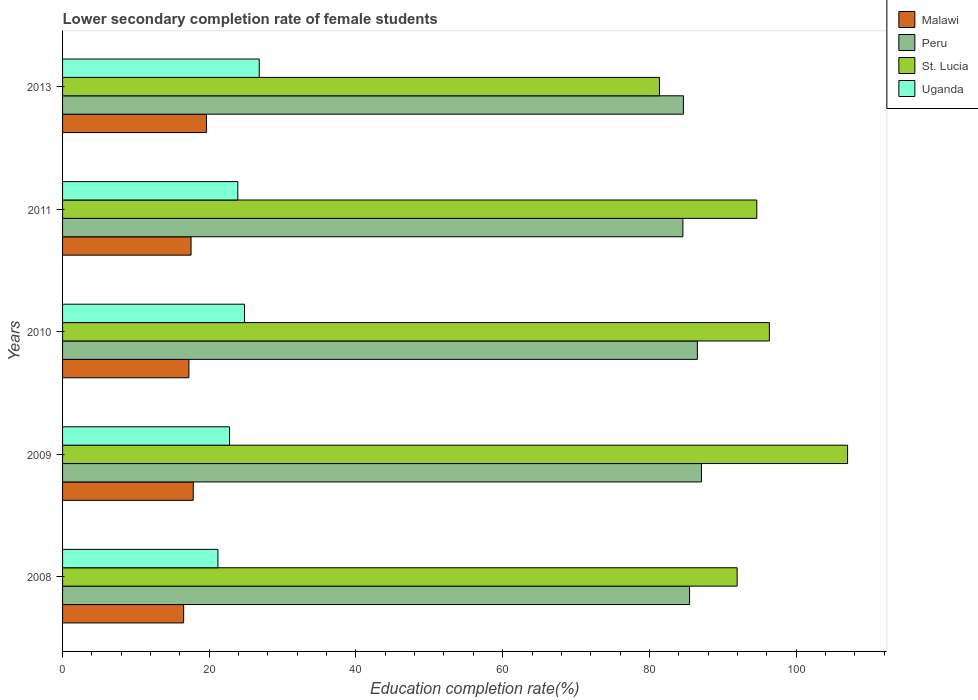How many different coloured bars are there?
Give a very brief answer. 4. How many groups of bars are there?
Your response must be concise. 5. Are the number of bars on each tick of the Y-axis equal?
Ensure brevity in your answer.  Yes. How many bars are there on the 3rd tick from the top?
Your answer should be compact. 4. What is the lower secondary completion rate of female students in Malawi in 2009?
Offer a very short reply. 17.82. Across all years, what is the maximum lower secondary completion rate of female students in St. Lucia?
Your answer should be compact. 107.03. Across all years, what is the minimum lower secondary completion rate of female students in Peru?
Make the answer very short. 84.57. In which year was the lower secondary completion rate of female students in St. Lucia maximum?
Offer a terse response. 2009. In which year was the lower secondary completion rate of female students in St. Lucia minimum?
Your response must be concise. 2013. What is the total lower secondary completion rate of female students in Uganda in the graph?
Ensure brevity in your answer.  119.46. What is the difference between the lower secondary completion rate of female students in St. Lucia in 2010 and that in 2011?
Offer a very short reply. 1.72. What is the difference between the lower secondary completion rate of female students in Uganda in 2009 and the lower secondary completion rate of female students in St. Lucia in 2008?
Offer a terse response. -69.2. What is the average lower secondary completion rate of female students in St. Lucia per year?
Offer a very short reply. 94.28. In the year 2013, what is the difference between the lower secondary completion rate of female students in Uganda and lower secondary completion rate of female students in St. Lucia?
Give a very brief answer. -54.56. What is the ratio of the lower secondary completion rate of female students in St. Lucia in 2008 to that in 2011?
Offer a terse response. 0.97. Is the difference between the lower secondary completion rate of female students in Uganda in 2009 and 2011 greater than the difference between the lower secondary completion rate of female students in St. Lucia in 2009 and 2011?
Ensure brevity in your answer.  No. What is the difference between the highest and the second highest lower secondary completion rate of female students in Peru?
Provide a short and direct response. 0.56. What is the difference between the highest and the lowest lower secondary completion rate of female students in Malawi?
Keep it short and to the point. 3.11. In how many years, is the lower secondary completion rate of female students in Peru greater than the average lower secondary completion rate of female students in Peru taken over all years?
Ensure brevity in your answer.  2. What does the 1st bar from the top in 2010 represents?
Provide a succinct answer. Uganda. What does the 1st bar from the bottom in 2008 represents?
Ensure brevity in your answer.  Malawi. Is it the case that in every year, the sum of the lower secondary completion rate of female students in Uganda and lower secondary completion rate of female students in St. Lucia is greater than the lower secondary completion rate of female students in Peru?
Give a very brief answer. Yes. How many bars are there?
Your answer should be compact. 20. Are all the bars in the graph horizontal?
Make the answer very short. Yes. What is the difference between two consecutive major ticks on the X-axis?
Give a very brief answer. 20. Where does the legend appear in the graph?
Give a very brief answer. Top right. How many legend labels are there?
Ensure brevity in your answer.  4. What is the title of the graph?
Ensure brevity in your answer.  Lower secondary completion rate of female students. Does "Aruba" appear as one of the legend labels in the graph?
Your answer should be very brief. No. What is the label or title of the X-axis?
Provide a short and direct response. Education completion rate(%). What is the Education completion rate(%) in Malawi in 2008?
Make the answer very short. 16.51. What is the Education completion rate(%) in Peru in 2008?
Offer a very short reply. 85.48. What is the Education completion rate(%) in St. Lucia in 2008?
Give a very brief answer. 91.97. What is the Education completion rate(%) in Uganda in 2008?
Your answer should be very brief. 21.18. What is the Education completion rate(%) in Malawi in 2009?
Give a very brief answer. 17.82. What is the Education completion rate(%) in Peru in 2009?
Ensure brevity in your answer.  87.1. What is the Education completion rate(%) in St. Lucia in 2009?
Keep it short and to the point. 107.03. What is the Education completion rate(%) in Uganda in 2009?
Give a very brief answer. 22.77. What is the Education completion rate(%) of Malawi in 2010?
Offer a very short reply. 17.22. What is the Education completion rate(%) in Peru in 2010?
Offer a very short reply. 86.54. What is the Education completion rate(%) in St. Lucia in 2010?
Your response must be concise. 96.36. What is the Education completion rate(%) in Uganda in 2010?
Offer a terse response. 24.8. What is the Education completion rate(%) in Malawi in 2011?
Offer a very short reply. 17.52. What is the Education completion rate(%) in Peru in 2011?
Keep it short and to the point. 84.57. What is the Education completion rate(%) of St. Lucia in 2011?
Ensure brevity in your answer.  94.65. What is the Education completion rate(%) of Uganda in 2011?
Your answer should be compact. 23.89. What is the Education completion rate(%) of Malawi in 2013?
Your answer should be compact. 19.62. What is the Education completion rate(%) in Peru in 2013?
Keep it short and to the point. 84.65. What is the Education completion rate(%) of St. Lucia in 2013?
Make the answer very short. 81.38. What is the Education completion rate(%) of Uganda in 2013?
Give a very brief answer. 26.81. Across all years, what is the maximum Education completion rate(%) in Malawi?
Make the answer very short. 19.62. Across all years, what is the maximum Education completion rate(%) of Peru?
Provide a short and direct response. 87.1. Across all years, what is the maximum Education completion rate(%) in St. Lucia?
Make the answer very short. 107.03. Across all years, what is the maximum Education completion rate(%) in Uganda?
Provide a short and direct response. 26.81. Across all years, what is the minimum Education completion rate(%) in Malawi?
Your response must be concise. 16.51. Across all years, what is the minimum Education completion rate(%) in Peru?
Give a very brief answer. 84.57. Across all years, what is the minimum Education completion rate(%) in St. Lucia?
Give a very brief answer. 81.38. Across all years, what is the minimum Education completion rate(%) in Uganda?
Provide a short and direct response. 21.18. What is the total Education completion rate(%) in Malawi in the graph?
Your response must be concise. 88.69. What is the total Education completion rate(%) of Peru in the graph?
Give a very brief answer. 428.35. What is the total Education completion rate(%) in St. Lucia in the graph?
Keep it short and to the point. 471.38. What is the total Education completion rate(%) in Uganda in the graph?
Offer a very short reply. 119.46. What is the difference between the Education completion rate(%) in Malawi in 2008 and that in 2009?
Give a very brief answer. -1.31. What is the difference between the Education completion rate(%) in Peru in 2008 and that in 2009?
Your response must be concise. -1.62. What is the difference between the Education completion rate(%) in St. Lucia in 2008 and that in 2009?
Your answer should be very brief. -15.06. What is the difference between the Education completion rate(%) of Uganda in 2008 and that in 2009?
Your answer should be compact. -1.58. What is the difference between the Education completion rate(%) of Malawi in 2008 and that in 2010?
Make the answer very short. -0.72. What is the difference between the Education completion rate(%) in Peru in 2008 and that in 2010?
Offer a terse response. -1.06. What is the difference between the Education completion rate(%) in St. Lucia in 2008 and that in 2010?
Your answer should be compact. -4.4. What is the difference between the Education completion rate(%) of Uganda in 2008 and that in 2010?
Keep it short and to the point. -3.62. What is the difference between the Education completion rate(%) in Malawi in 2008 and that in 2011?
Give a very brief answer. -1.01. What is the difference between the Education completion rate(%) of Peru in 2008 and that in 2011?
Give a very brief answer. 0.91. What is the difference between the Education completion rate(%) in St. Lucia in 2008 and that in 2011?
Your answer should be compact. -2.68. What is the difference between the Education completion rate(%) in Uganda in 2008 and that in 2011?
Ensure brevity in your answer.  -2.71. What is the difference between the Education completion rate(%) in Malawi in 2008 and that in 2013?
Provide a succinct answer. -3.11. What is the difference between the Education completion rate(%) in Peru in 2008 and that in 2013?
Your answer should be compact. 0.84. What is the difference between the Education completion rate(%) of St. Lucia in 2008 and that in 2013?
Provide a short and direct response. 10.59. What is the difference between the Education completion rate(%) in Uganda in 2008 and that in 2013?
Your answer should be very brief. -5.63. What is the difference between the Education completion rate(%) in Malawi in 2009 and that in 2010?
Offer a very short reply. 0.59. What is the difference between the Education completion rate(%) of Peru in 2009 and that in 2010?
Ensure brevity in your answer.  0.56. What is the difference between the Education completion rate(%) of St. Lucia in 2009 and that in 2010?
Offer a very short reply. 10.66. What is the difference between the Education completion rate(%) in Uganda in 2009 and that in 2010?
Ensure brevity in your answer.  -2.04. What is the difference between the Education completion rate(%) of Malawi in 2009 and that in 2011?
Provide a short and direct response. 0.3. What is the difference between the Education completion rate(%) of Peru in 2009 and that in 2011?
Your response must be concise. 2.53. What is the difference between the Education completion rate(%) of St. Lucia in 2009 and that in 2011?
Make the answer very short. 12.38. What is the difference between the Education completion rate(%) in Uganda in 2009 and that in 2011?
Make the answer very short. -1.13. What is the difference between the Education completion rate(%) in Malawi in 2009 and that in 2013?
Your answer should be very brief. -1.8. What is the difference between the Education completion rate(%) of Peru in 2009 and that in 2013?
Provide a short and direct response. 2.46. What is the difference between the Education completion rate(%) in St. Lucia in 2009 and that in 2013?
Ensure brevity in your answer.  25.65. What is the difference between the Education completion rate(%) in Uganda in 2009 and that in 2013?
Offer a very short reply. -4.05. What is the difference between the Education completion rate(%) of Malawi in 2010 and that in 2011?
Provide a succinct answer. -0.29. What is the difference between the Education completion rate(%) of Peru in 2010 and that in 2011?
Provide a short and direct response. 1.97. What is the difference between the Education completion rate(%) in St. Lucia in 2010 and that in 2011?
Offer a terse response. 1.72. What is the difference between the Education completion rate(%) of Uganda in 2010 and that in 2011?
Offer a very short reply. 0.91. What is the difference between the Education completion rate(%) in Malawi in 2010 and that in 2013?
Ensure brevity in your answer.  -2.39. What is the difference between the Education completion rate(%) in Peru in 2010 and that in 2013?
Give a very brief answer. 1.9. What is the difference between the Education completion rate(%) of St. Lucia in 2010 and that in 2013?
Make the answer very short. 14.99. What is the difference between the Education completion rate(%) in Uganda in 2010 and that in 2013?
Give a very brief answer. -2.01. What is the difference between the Education completion rate(%) in Malawi in 2011 and that in 2013?
Offer a terse response. -2.1. What is the difference between the Education completion rate(%) in Peru in 2011 and that in 2013?
Ensure brevity in your answer.  -0.07. What is the difference between the Education completion rate(%) in St. Lucia in 2011 and that in 2013?
Your answer should be very brief. 13.27. What is the difference between the Education completion rate(%) in Uganda in 2011 and that in 2013?
Offer a very short reply. -2.92. What is the difference between the Education completion rate(%) in Malawi in 2008 and the Education completion rate(%) in Peru in 2009?
Your response must be concise. -70.59. What is the difference between the Education completion rate(%) in Malawi in 2008 and the Education completion rate(%) in St. Lucia in 2009?
Provide a succinct answer. -90.52. What is the difference between the Education completion rate(%) of Malawi in 2008 and the Education completion rate(%) of Uganda in 2009?
Ensure brevity in your answer.  -6.26. What is the difference between the Education completion rate(%) in Peru in 2008 and the Education completion rate(%) in St. Lucia in 2009?
Keep it short and to the point. -21.54. What is the difference between the Education completion rate(%) of Peru in 2008 and the Education completion rate(%) of Uganda in 2009?
Provide a short and direct response. 62.72. What is the difference between the Education completion rate(%) of St. Lucia in 2008 and the Education completion rate(%) of Uganda in 2009?
Make the answer very short. 69.2. What is the difference between the Education completion rate(%) of Malawi in 2008 and the Education completion rate(%) of Peru in 2010?
Offer a terse response. -70.04. What is the difference between the Education completion rate(%) of Malawi in 2008 and the Education completion rate(%) of St. Lucia in 2010?
Your answer should be very brief. -79.85. What is the difference between the Education completion rate(%) in Malawi in 2008 and the Education completion rate(%) in Uganda in 2010?
Offer a very short reply. -8.29. What is the difference between the Education completion rate(%) in Peru in 2008 and the Education completion rate(%) in St. Lucia in 2010?
Offer a very short reply. -10.88. What is the difference between the Education completion rate(%) in Peru in 2008 and the Education completion rate(%) in Uganda in 2010?
Your answer should be very brief. 60.68. What is the difference between the Education completion rate(%) in St. Lucia in 2008 and the Education completion rate(%) in Uganda in 2010?
Provide a short and direct response. 67.17. What is the difference between the Education completion rate(%) of Malawi in 2008 and the Education completion rate(%) of Peru in 2011?
Provide a succinct answer. -68.06. What is the difference between the Education completion rate(%) in Malawi in 2008 and the Education completion rate(%) in St. Lucia in 2011?
Your answer should be very brief. -78.14. What is the difference between the Education completion rate(%) in Malawi in 2008 and the Education completion rate(%) in Uganda in 2011?
Your answer should be compact. -7.38. What is the difference between the Education completion rate(%) of Peru in 2008 and the Education completion rate(%) of St. Lucia in 2011?
Make the answer very short. -9.16. What is the difference between the Education completion rate(%) in Peru in 2008 and the Education completion rate(%) in Uganda in 2011?
Your response must be concise. 61.59. What is the difference between the Education completion rate(%) in St. Lucia in 2008 and the Education completion rate(%) in Uganda in 2011?
Ensure brevity in your answer.  68.08. What is the difference between the Education completion rate(%) in Malawi in 2008 and the Education completion rate(%) in Peru in 2013?
Ensure brevity in your answer.  -68.14. What is the difference between the Education completion rate(%) of Malawi in 2008 and the Education completion rate(%) of St. Lucia in 2013?
Make the answer very short. -64.87. What is the difference between the Education completion rate(%) of Malawi in 2008 and the Education completion rate(%) of Uganda in 2013?
Make the answer very short. -10.31. What is the difference between the Education completion rate(%) in Peru in 2008 and the Education completion rate(%) in St. Lucia in 2013?
Make the answer very short. 4.11. What is the difference between the Education completion rate(%) in Peru in 2008 and the Education completion rate(%) in Uganda in 2013?
Keep it short and to the point. 58.67. What is the difference between the Education completion rate(%) of St. Lucia in 2008 and the Education completion rate(%) of Uganda in 2013?
Give a very brief answer. 65.15. What is the difference between the Education completion rate(%) in Malawi in 2009 and the Education completion rate(%) in Peru in 2010?
Your answer should be compact. -68.73. What is the difference between the Education completion rate(%) in Malawi in 2009 and the Education completion rate(%) in St. Lucia in 2010?
Give a very brief answer. -78.54. What is the difference between the Education completion rate(%) of Malawi in 2009 and the Education completion rate(%) of Uganda in 2010?
Offer a very short reply. -6.98. What is the difference between the Education completion rate(%) in Peru in 2009 and the Education completion rate(%) in St. Lucia in 2010?
Provide a short and direct response. -9.26. What is the difference between the Education completion rate(%) of Peru in 2009 and the Education completion rate(%) of Uganda in 2010?
Provide a succinct answer. 62.3. What is the difference between the Education completion rate(%) in St. Lucia in 2009 and the Education completion rate(%) in Uganda in 2010?
Keep it short and to the point. 82.22. What is the difference between the Education completion rate(%) in Malawi in 2009 and the Education completion rate(%) in Peru in 2011?
Ensure brevity in your answer.  -66.75. What is the difference between the Education completion rate(%) of Malawi in 2009 and the Education completion rate(%) of St. Lucia in 2011?
Your answer should be very brief. -76.83. What is the difference between the Education completion rate(%) of Malawi in 2009 and the Education completion rate(%) of Uganda in 2011?
Your response must be concise. -6.07. What is the difference between the Education completion rate(%) in Peru in 2009 and the Education completion rate(%) in St. Lucia in 2011?
Keep it short and to the point. -7.55. What is the difference between the Education completion rate(%) in Peru in 2009 and the Education completion rate(%) in Uganda in 2011?
Offer a very short reply. 63.21. What is the difference between the Education completion rate(%) of St. Lucia in 2009 and the Education completion rate(%) of Uganda in 2011?
Keep it short and to the point. 83.13. What is the difference between the Education completion rate(%) in Malawi in 2009 and the Education completion rate(%) in Peru in 2013?
Your response must be concise. -66.83. What is the difference between the Education completion rate(%) of Malawi in 2009 and the Education completion rate(%) of St. Lucia in 2013?
Make the answer very short. -63.56. What is the difference between the Education completion rate(%) of Malawi in 2009 and the Education completion rate(%) of Uganda in 2013?
Provide a short and direct response. -9. What is the difference between the Education completion rate(%) of Peru in 2009 and the Education completion rate(%) of St. Lucia in 2013?
Your answer should be very brief. 5.72. What is the difference between the Education completion rate(%) of Peru in 2009 and the Education completion rate(%) of Uganda in 2013?
Offer a terse response. 60.29. What is the difference between the Education completion rate(%) of St. Lucia in 2009 and the Education completion rate(%) of Uganda in 2013?
Provide a short and direct response. 80.21. What is the difference between the Education completion rate(%) of Malawi in 2010 and the Education completion rate(%) of Peru in 2011?
Keep it short and to the point. -67.35. What is the difference between the Education completion rate(%) in Malawi in 2010 and the Education completion rate(%) in St. Lucia in 2011?
Keep it short and to the point. -77.42. What is the difference between the Education completion rate(%) in Malawi in 2010 and the Education completion rate(%) in Uganda in 2011?
Offer a very short reply. -6.67. What is the difference between the Education completion rate(%) of Peru in 2010 and the Education completion rate(%) of St. Lucia in 2011?
Provide a short and direct response. -8.1. What is the difference between the Education completion rate(%) in Peru in 2010 and the Education completion rate(%) in Uganda in 2011?
Keep it short and to the point. 62.65. What is the difference between the Education completion rate(%) in St. Lucia in 2010 and the Education completion rate(%) in Uganda in 2011?
Keep it short and to the point. 72.47. What is the difference between the Education completion rate(%) in Malawi in 2010 and the Education completion rate(%) in Peru in 2013?
Ensure brevity in your answer.  -67.42. What is the difference between the Education completion rate(%) of Malawi in 2010 and the Education completion rate(%) of St. Lucia in 2013?
Your response must be concise. -64.15. What is the difference between the Education completion rate(%) of Malawi in 2010 and the Education completion rate(%) of Uganda in 2013?
Your answer should be very brief. -9.59. What is the difference between the Education completion rate(%) in Peru in 2010 and the Education completion rate(%) in St. Lucia in 2013?
Your response must be concise. 5.17. What is the difference between the Education completion rate(%) in Peru in 2010 and the Education completion rate(%) in Uganda in 2013?
Your answer should be very brief. 59.73. What is the difference between the Education completion rate(%) in St. Lucia in 2010 and the Education completion rate(%) in Uganda in 2013?
Make the answer very short. 69.55. What is the difference between the Education completion rate(%) in Malawi in 2011 and the Education completion rate(%) in Peru in 2013?
Make the answer very short. -67.13. What is the difference between the Education completion rate(%) of Malawi in 2011 and the Education completion rate(%) of St. Lucia in 2013?
Ensure brevity in your answer.  -63.86. What is the difference between the Education completion rate(%) in Malawi in 2011 and the Education completion rate(%) in Uganda in 2013?
Offer a terse response. -9.29. What is the difference between the Education completion rate(%) in Peru in 2011 and the Education completion rate(%) in St. Lucia in 2013?
Provide a short and direct response. 3.19. What is the difference between the Education completion rate(%) in Peru in 2011 and the Education completion rate(%) in Uganda in 2013?
Your answer should be very brief. 57.76. What is the difference between the Education completion rate(%) in St. Lucia in 2011 and the Education completion rate(%) in Uganda in 2013?
Offer a very short reply. 67.83. What is the average Education completion rate(%) in Malawi per year?
Ensure brevity in your answer.  17.74. What is the average Education completion rate(%) of Peru per year?
Offer a terse response. 85.67. What is the average Education completion rate(%) of St. Lucia per year?
Give a very brief answer. 94.28. What is the average Education completion rate(%) in Uganda per year?
Keep it short and to the point. 23.89. In the year 2008, what is the difference between the Education completion rate(%) in Malawi and Education completion rate(%) in Peru?
Keep it short and to the point. -68.98. In the year 2008, what is the difference between the Education completion rate(%) of Malawi and Education completion rate(%) of St. Lucia?
Provide a succinct answer. -75.46. In the year 2008, what is the difference between the Education completion rate(%) in Malawi and Education completion rate(%) in Uganda?
Provide a succinct answer. -4.68. In the year 2008, what is the difference between the Education completion rate(%) in Peru and Education completion rate(%) in St. Lucia?
Provide a short and direct response. -6.48. In the year 2008, what is the difference between the Education completion rate(%) of Peru and Education completion rate(%) of Uganda?
Your response must be concise. 64.3. In the year 2008, what is the difference between the Education completion rate(%) in St. Lucia and Education completion rate(%) in Uganda?
Ensure brevity in your answer.  70.78. In the year 2009, what is the difference between the Education completion rate(%) of Malawi and Education completion rate(%) of Peru?
Your answer should be compact. -69.28. In the year 2009, what is the difference between the Education completion rate(%) in Malawi and Education completion rate(%) in St. Lucia?
Offer a terse response. -89.21. In the year 2009, what is the difference between the Education completion rate(%) in Malawi and Education completion rate(%) in Uganda?
Your answer should be very brief. -4.95. In the year 2009, what is the difference between the Education completion rate(%) in Peru and Education completion rate(%) in St. Lucia?
Make the answer very short. -19.93. In the year 2009, what is the difference between the Education completion rate(%) in Peru and Education completion rate(%) in Uganda?
Your answer should be very brief. 64.33. In the year 2009, what is the difference between the Education completion rate(%) of St. Lucia and Education completion rate(%) of Uganda?
Give a very brief answer. 84.26. In the year 2010, what is the difference between the Education completion rate(%) in Malawi and Education completion rate(%) in Peru?
Offer a terse response. -69.32. In the year 2010, what is the difference between the Education completion rate(%) of Malawi and Education completion rate(%) of St. Lucia?
Your answer should be compact. -79.14. In the year 2010, what is the difference between the Education completion rate(%) of Malawi and Education completion rate(%) of Uganda?
Ensure brevity in your answer.  -7.58. In the year 2010, what is the difference between the Education completion rate(%) of Peru and Education completion rate(%) of St. Lucia?
Make the answer very short. -9.82. In the year 2010, what is the difference between the Education completion rate(%) of Peru and Education completion rate(%) of Uganda?
Ensure brevity in your answer.  61.74. In the year 2010, what is the difference between the Education completion rate(%) in St. Lucia and Education completion rate(%) in Uganda?
Keep it short and to the point. 71.56. In the year 2011, what is the difference between the Education completion rate(%) in Malawi and Education completion rate(%) in Peru?
Your answer should be compact. -67.05. In the year 2011, what is the difference between the Education completion rate(%) of Malawi and Education completion rate(%) of St. Lucia?
Provide a short and direct response. -77.13. In the year 2011, what is the difference between the Education completion rate(%) of Malawi and Education completion rate(%) of Uganda?
Make the answer very short. -6.37. In the year 2011, what is the difference between the Education completion rate(%) in Peru and Education completion rate(%) in St. Lucia?
Ensure brevity in your answer.  -10.08. In the year 2011, what is the difference between the Education completion rate(%) of Peru and Education completion rate(%) of Uganda?
Your answer should be compact. 60.68. In the year 2011, what is the difference between the Education completion rate(%) of St. Lucia and Education completion rate(%) of Uganda?
Your answer should be very brief. 70.76. In the year 2013, what is the difference between the Education completion rate(%) of Malawi and Education completion rate(%) of Peru?
Keep it short and to the point. -65.03. In the year 2013, what is the difference between the Education completion rate(%) of Malawi and Education completion rate(%) of St. Lucia?
Offer a very short reply. -61.76. In the year 2013, what is the difference between the Education completion rate(%) of Malawi and Education completion rate(%) of Uganda?
Give a very brief answer. -7.19. In the year 2013, what is the difference between the Education completion rate(%) in Peru and Education completion rate(%) in St. Lucia?
Provide a succinct answer. 3.27. In the year 2013, what is the difference between the Education completion rate(%) in Peru and Education completion rate(%) in Uganda?
Make the answer very short. 57.83. In the year 2013, what is the difference between the Education completion rate(%) in St. Lucia and Education completion rate(%) in Uganda?
Keep it short and to the point. 54.56. What is the ratio of the Education completion rate(%) in Malawi in 2008 to that in 2009?
Provide a short and direct response. 0.93. What is the ratio of the Education completion rate(%) in Peru in 2008 to that in 2009?
Your answer should be compact. 0.98. What is the ratio of the Education completion rate(%) of St. Lucia in 2008 to that in 2009?
Your response must be concise. 0.86. What is the ratio of the Education completion rate(%) in Uganda in 2008 to that in 2009?
Make the answer very short. 0.93. What is the ratio of the Education completion rate(%) in Malawi in 2008 to that in 2010?
Your response must be concise. 0.96. What is the ratio of the Education completion rate(%) in Peru in 2008 to that in 2010?
Offer a terse response. 0.99. What is the ratio of the Education completion rate(%) in St. Lucia in 2008 to that in 2010?
Provide a succinct answer. 0.95. What is the ratio of the Education completion rate(%) in Uganda in 2008 to that in 2010?
Your answer should be compact. 0.85. What is the ratio of the Education completion rate(%) of Malawi in 2008 to that in 2011?
Your answer should be very brief. 0.94. What is the ratio of the Education completion rate(%) of Peru in 2008 to that in 2011?
Your answer should be very brief. 1.01. What is the ratio of the Education completion rate(%) in St. Lucia in 2008 to that in 2011?
Your response must be concise. 0.97. What is the ratio of the Education completion rate(%) in Uganda in 2008 to that in 2011?
Give a very brief answer. 0.89. What is the ratio of the Education completion rate(%) of Malawi in 2008 to that in 2013?
Provide a succinct answer. 0.84. What is the ratio of the Education completion rate(%) of Peru in 2008 to that in 2013?
Give a very brief answer. 1.01. What is the ratio of the Education completion rate(%) of St. Lucia in 2008 to that in 2013?
Offer a terse response. 1.13. What is the ratio of the Education completion rate(%) of Uganda in 2008 to that in 2013?
Your response must be concise. 0.79. What is the ratio of the Education completion rate(%) of Malawi in 2009 to that in 2010?
Ensure brevity in your answer.  1.03. What is the ratio of the Education completion rate(%) of Peru in 2009 to that in 2010?
Offer a terse response. 1.01. What is the ratio of the Education completion rate(%) in St. Lucia in 2009 to that in 2010?
Your answer should be very brief. 1.11. What is the ratio of the Education completion rate(%) of Uganda in 2009 to that in 2010?
Make the answer very short. 0.92. What is the ratio of the Education completion rate(%) of Malawi in 2009 to that in 2011?
Keep it short and to the point. 1.02. What is the ratio of the Education completion rate(%) of Peru in 2009 to that in 2011?
Offer a terse response. 1.03. What is the ratio of the Education completion rate(%) of St. Lucia in 2009 to that in 2011?
Provide a succinct answer. 1.13. What is the ratio of the Education completion rate(%) in Uganda in 2009 to that in 2011?
Provide a short and direct response. 0.95. What is the ratio of the Education completion rate(%) in Malawi in 2009 to that in 2013?
Offer a terse response. 0.91. What is the ratio of the Education completion rate(%) of St. Lucia in 2009 to that in 2013?
Ensure brevity in your answer.  1.32. What is the ratio of the Education completion rate(%) in Uganda in 2009 to that in 2013?
Keep it short and to the point. 0.85. What is the ratio of the Education completion rate(%) of Malawi in 2010 to that in 2011?
Your answer should be compact. 0.98. What is the ratio of the Education completion rate(%) of Peru in 2010 to that in 2011?
Your answer should be compact. 1.02. What is the ratio of the Education completion rate(%) of St. Lucia in 2010 to that in 2011?
Your response must be concise. 1.02. What is the ratio of the Education completion rate(%) of Uganda in 2010 to that in 2011?
Provide a short and direct response. 1.04. What is the ratio of the Education completion rate(%) of Malawi in 2010 to that in 2013?
Offer a very short reply. 0.88. What is the ratio of the Education completion rate(%) in Peru in 2010 to that in 2013?
Keep it short and to the point. 1.02. What is the ratio of the Education completion rate(%) in St. Lucia in 2010 to that in 2013?
Ensure brevity in your answer.  1.18. What is the ratio of the Education completion rate(%) of Uganda in 2010 to that in 2013?
Your answer should be very brief. 0.93. What is the ratio of the Education completion rate(%) in Malawi in 2011 to that in 2013?
Provide a short and direct response. 0.89. What is the ratio of the Education completion rate(%) in St. Lucia in 2011 to that in 2013?
Your answer should be very brief. 1.16. What is the ratio of the Education completion rate(%) of Uganda in 2011 to that in 2013?
Offer a terse response. 0.89. What is the difference between the highest and the second highest Education completion rate(%) in Malawi?
Provide a succinct answer. 1.8. What is the difference between the highest and the second highest Education completion rate(%) in Peru?
Give a very brief answer. 0.56. What is the difference between the highest and the second highest Education completion rate(%) in St. Lucia?
Your answer should be very brief. 10.66. What is the difference between the highest and the second highest Education completion rate(%) in Uganda?
Give a very brief answer. 2.01. What is the difference between the highest and the lowest Education completion rate(%) in Malawi?
Ensure brevity in your answer.  3.11. What is the difference between the highest and the lowest Education completion rate(%) of Peru?
Offer a very short reply. 2.53. What is the difference between the highest and the lowest Education completion rate(%) in St. Lucia?
Provide a succinct answer. 25.65. What is the difference between the highest and the lowest Education completion rate(%) of Uganda?
Offer a very short reply. 5.63. 